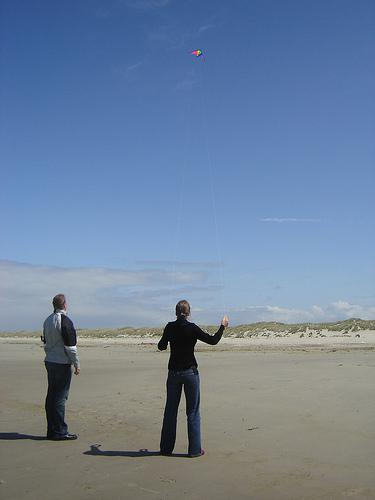Question: why are the people looking up?
Choices:
A. They're watching the plane.
B. They're watching the kite.
C. They are watching the clouds.
D. They're watching the helicopter.
Answer with the letter. Answer: B Question: what are the people doing?
Choices:
A. Talking.
B. Flying a kite.
C. Taking pictures.
D. Dancing.
Answer with the letter. Answer: B Question: what are the people both wearing?
Choices:
A. Shirts.
B. Jeans.
C. Coats.
D. Shoes.
Answer with the letter. Answer: B Question: what is in the sky other than the kite?
Choices:
A. Clouds.
B. Planes.
C. Helicopters.
D. Birds.
Answer with the letter. Answer: A Question: how are the people keeping the kite from flying away?
Choices:
A. They have a string.
B. The have it tied.
C. They are holding the string.
D. The have a weight on the end of the string.
Answer with the letter. Answer: A 